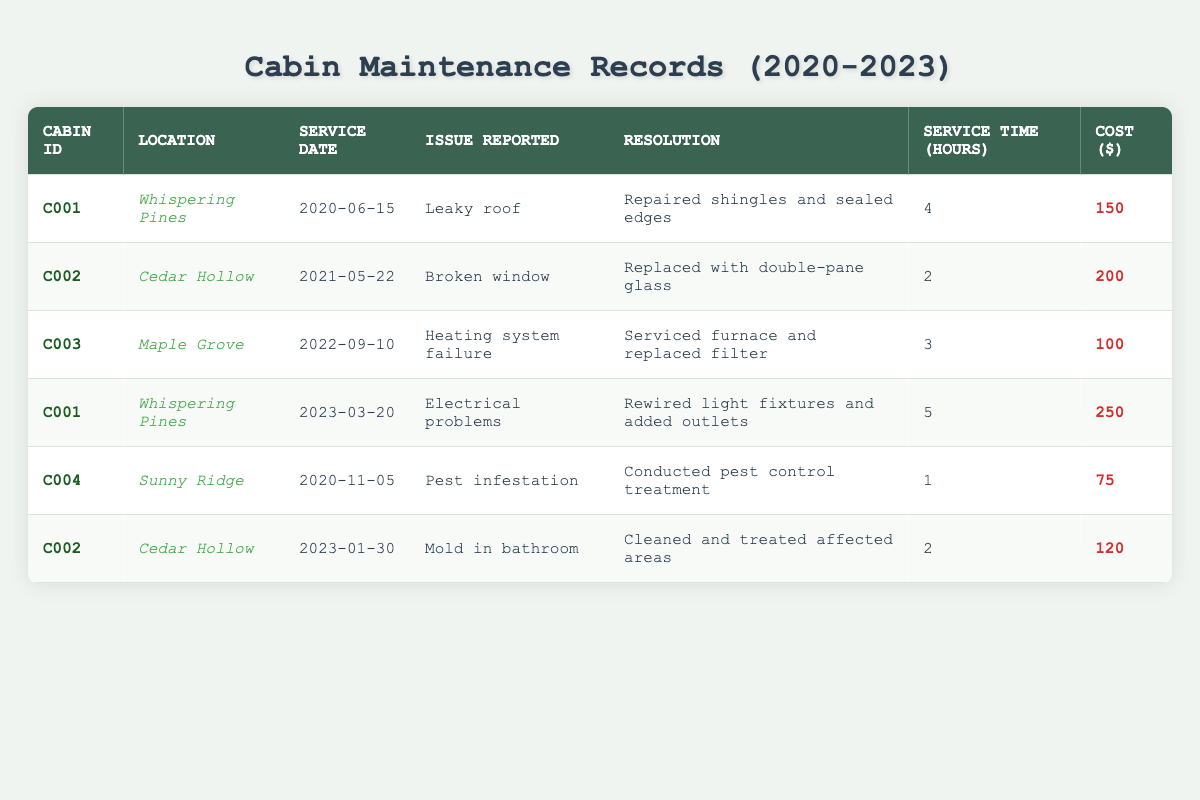What issue was reported at the Cedar Hollow cabin? From the table, we can find the row with the location "Cedar Hollow." This cabin appears twice, first on May 22, 2021, with a reported issue of "Broken window," and again on January 30, 2023, with "Mold in bathroom."
Answer: Mold in bathroom How many hours were spent on maintenance for the Whispering Pines cabin? By looking at the rows for "Whispering Pines," there are two entries: one on June 15, 2020, which took 4 hours, and another on March 20, 2023, which took 5 hours. The total service time is 4 + 5 = 9 hours.
Answer: 9 hours What was the total cost for maintenance work across all cabins in 2022? The only maintenance record from 2022 is from Maple Grove on September 10, 2022, with a cost of 100. Thus, the total cost for maintenance in 2022 is simply 100.
Answer: 100 Did any cabin report a pest infestation? Checking the table for the issue "Pest infestation," we find that it was reported at the Sunny Ridge cabin on November 5, 2020. Therefore, the answer is yes.
Answer: Yes Which cabin had the highest maintenance cost, and what was the amount? Analyzing the costs, the expenses for each cabin are: Whispering Pines $150 (first entry) and $250 (second entry), Cedar Hollow $200 (first entry) and $120 (second entry), Maple Grove $100, and Sunny Ridge $75. The highest from these is $250 from Whispering Pines.
Answer: Whispering Pines, 250 How much was spent on service requests for the Cedar Hollow cabin in total? The Cedar Hollow cabin has two service requests: one costing 200 in 2021 and another 120 in 2023. Adding these gives us 200 + 120 = 320.
Answer: 320 How many total maintenance requests were recorded from 2020 to 2023? Counting the rows in the table, we have six maintenance records that correspond to the years 2020, 2021, 2022, and 2023. Thus, the total number of requests is 6.
Answer: 6 Was the issue of "Heating system failure" reported more than once in this dataset? Searching through the table for "Heating system failure," we find it reported only once, in the entry for Maple Grove on September 10, 2022. Therefore, the answer is no.
Answer: No What is the average cost of maintenance across all records? To find the average cost, we must sum the costs (150 + 200 + 100 + 250 + 75 + 120 = 895) and divide by the number of records (6). So, 895 / 6 = 149.167, which rounds to approximately 149.17.
Answer: 149.17 